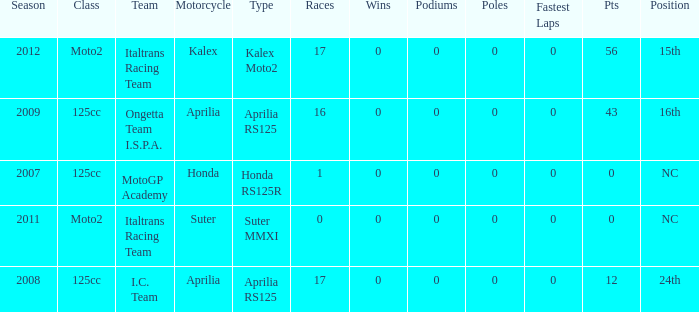What's Italtrans Racing Team's, with 0 pts, class? Moto2. 